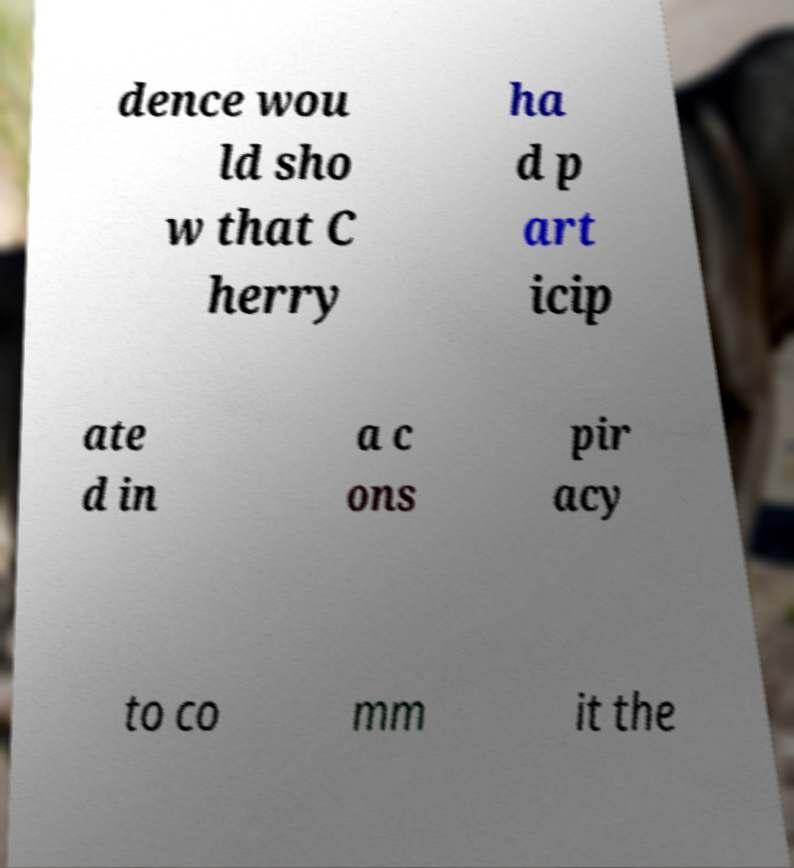Could you assist in decoding the text presented in this image and type it out clearly? dence wou ld sho w that C herry ha d p art icip ate d in a c ons pir acy to co mm it the 